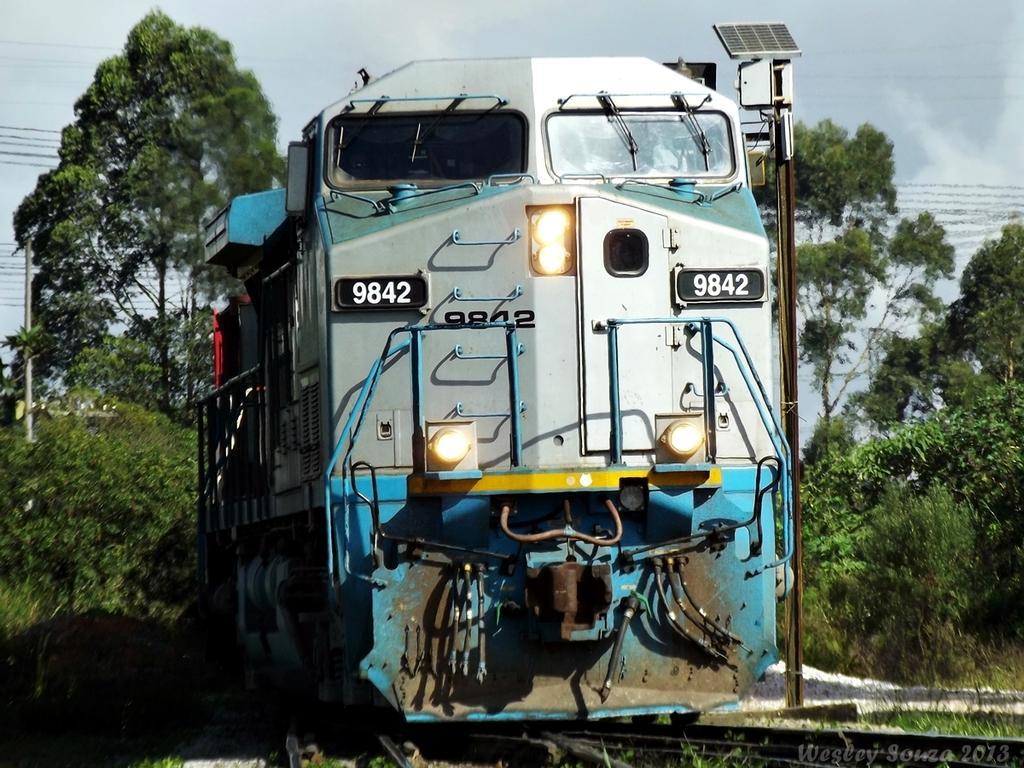Could you give a brief overview of what you see in this image? In this image, I can see a locomotive on the railway track. Beside the locomotive, there is a solar panel to a pole. On the left and right side of the image, I can see the trees and plants. In the background, I can see the wires and there is the sky. 